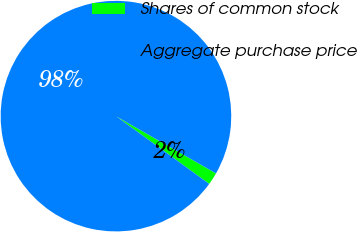Convert chart to OTSL. <chart><loc_0><loc_0><loc_500><loc_500><pie_chart><fcel>Shares of common stock<fcel>Aggregate purchase price<nl><fcel>1.73%<fcel>98.27%<nl></chart> 